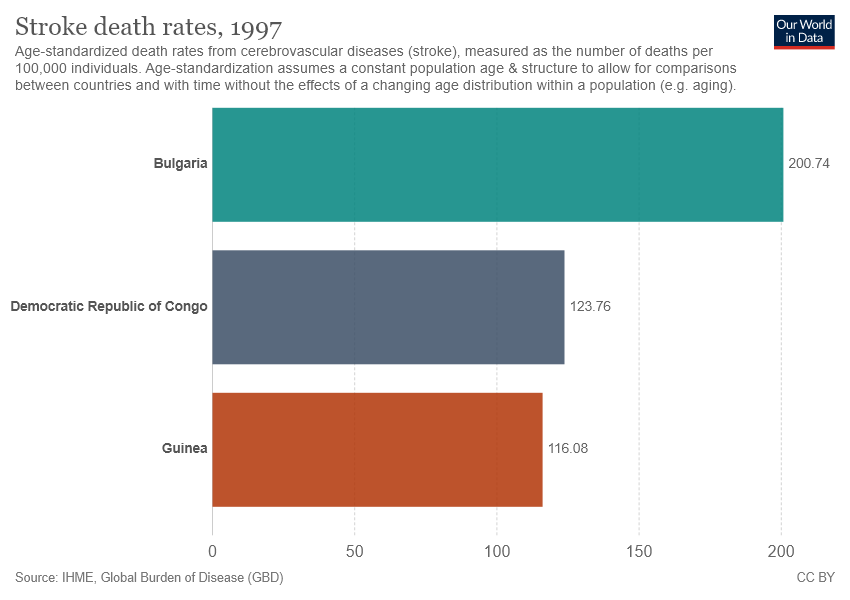Identify some key points in this picture. Guinea is not more valuable than the Democratic Republic of Congo. Guinea has the lowest stroke death rates among all the places studied. 